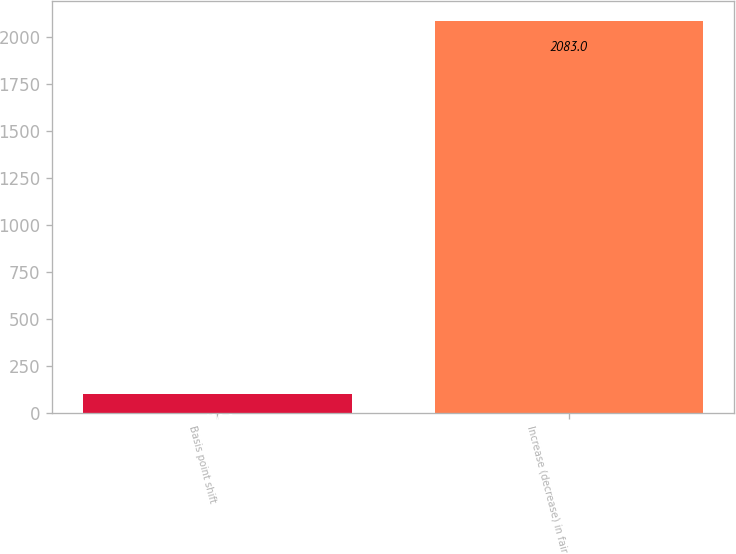Convert chart to OTSL. <chart><loc_0><loc_0><loc_500><loc_500><bar_chart><fcel>Basis point shift<fcel>Increase (decrease) in fair<nl><fcel>100<fcel>2083<nl></chart> 